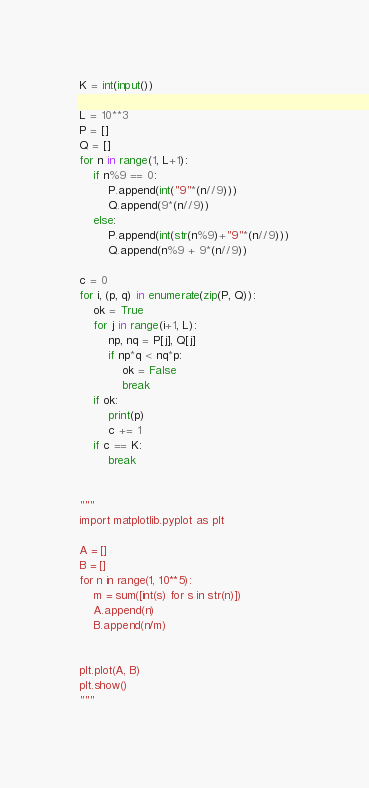<code> <loc_0><loc_0><loc_500><loc_500><_Python_>K = int(input())

L = 10**3
P = []
Q = []
for n in range(1, L+1):
    if n%9 == 0:
        P.append(int("9"*(n//9)))
        Q.append(9*(n//9))
    else:
        P.append(int(str(n%9)+"9"*(n//9)))
        Q.append(n%9 + 9*(n//9))

c = 0
for i, (p, q) in enumerate(zip(P, Q)):
    ok = True
    for j in range(i+1, L):
        np, nq = P[j], Q[j]
        if np*q < nq*p:
            ok = False
            break
    if ok:
        print(p)
        c += 1
    if c == K:
        break


"""
import matplotlib.pyplot as plt

A = []
B = []
for n in range(1, 10**5):
    m = sum([int(s) for s in str(n)])
    A.append(n)
    B.append(n/m)


plt.plot(A, B)
plt.show()
"""</code> 